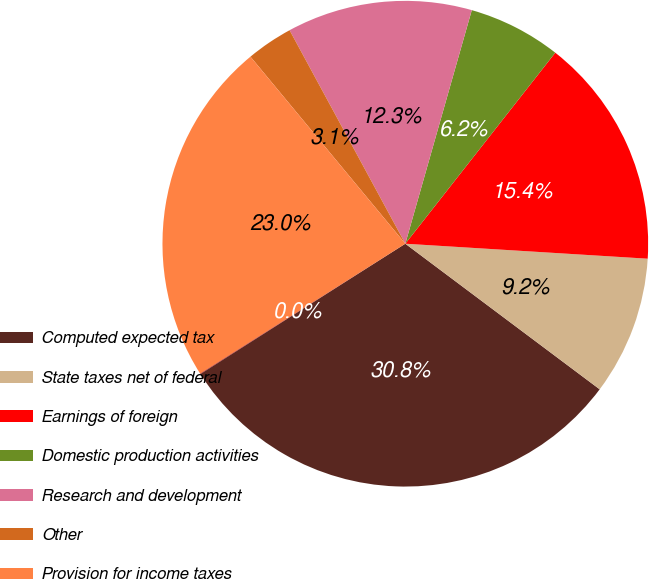Convert chart to OTSL. <chart><loc_0><loc_0><loc_500><loc_500><pie_chart><fcel>Computed expected tax<fcel>State taxes net of federal<fcel>Earnings of foreign<fcel>Domestic production activities<fcel>Research and development<fcel>Other<fcel>Provision for income taxes<fcel>Effective tax rate<nl><fcel>30.75%<fcel>9.25%<fcel>15.39%<fcel>6.18%<fcel>12.32%<fcel>3.1%<fcel>22.98%<fcel>0.03%<nl></chart> 